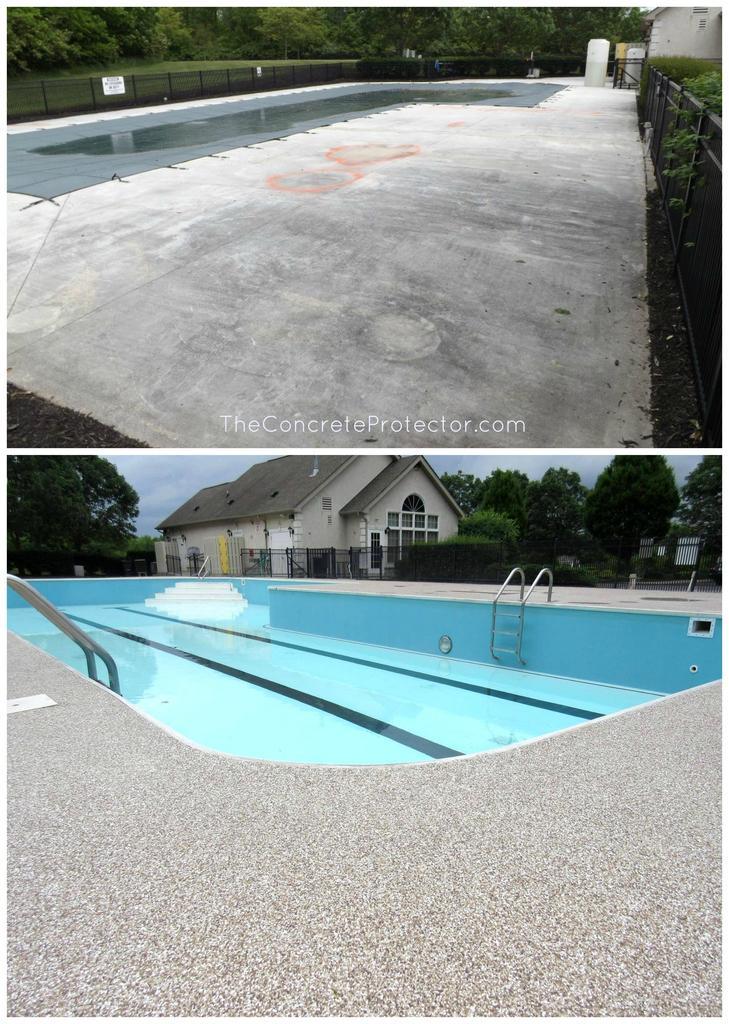How would you summarize this image in a sentence or two? In this image I can see a swimming pool, house, fence, trees, text and the sky. This image looks like an edited photo. 